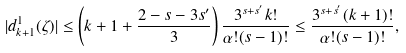<formula> <loc_0><loc_0><loc_500><loc_500>| d ^ { 1 } _ { k + 1 } ( \zeta ) | \leq \left ( k + 1 + \frac { 2 - s - 3 s ^ { \prime } } { 3 } \right ) \frac { 3 ^ { s + s ^ { \prime } } k ! } { \alpha ! ( s - 1 ) ! } \leq \frac { 3 ^ { s + s ^ { \prime } } ( k + 1 ) ! } { \alpha ! ( s - 1 ) ! } ,</formula> 